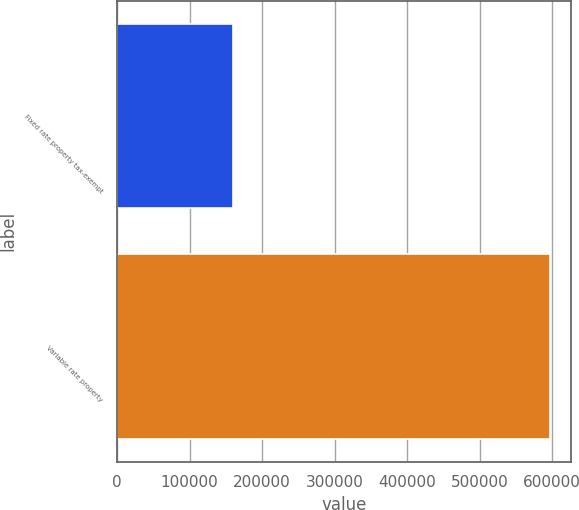<chart> <loc_0><loc_0><loc_500><loc_500><bar_chart><fcel>Fixed rate property tax-exempt<fcel>Variable rate property<nl><fcel>159893<fcel>596549<nl></chart> 